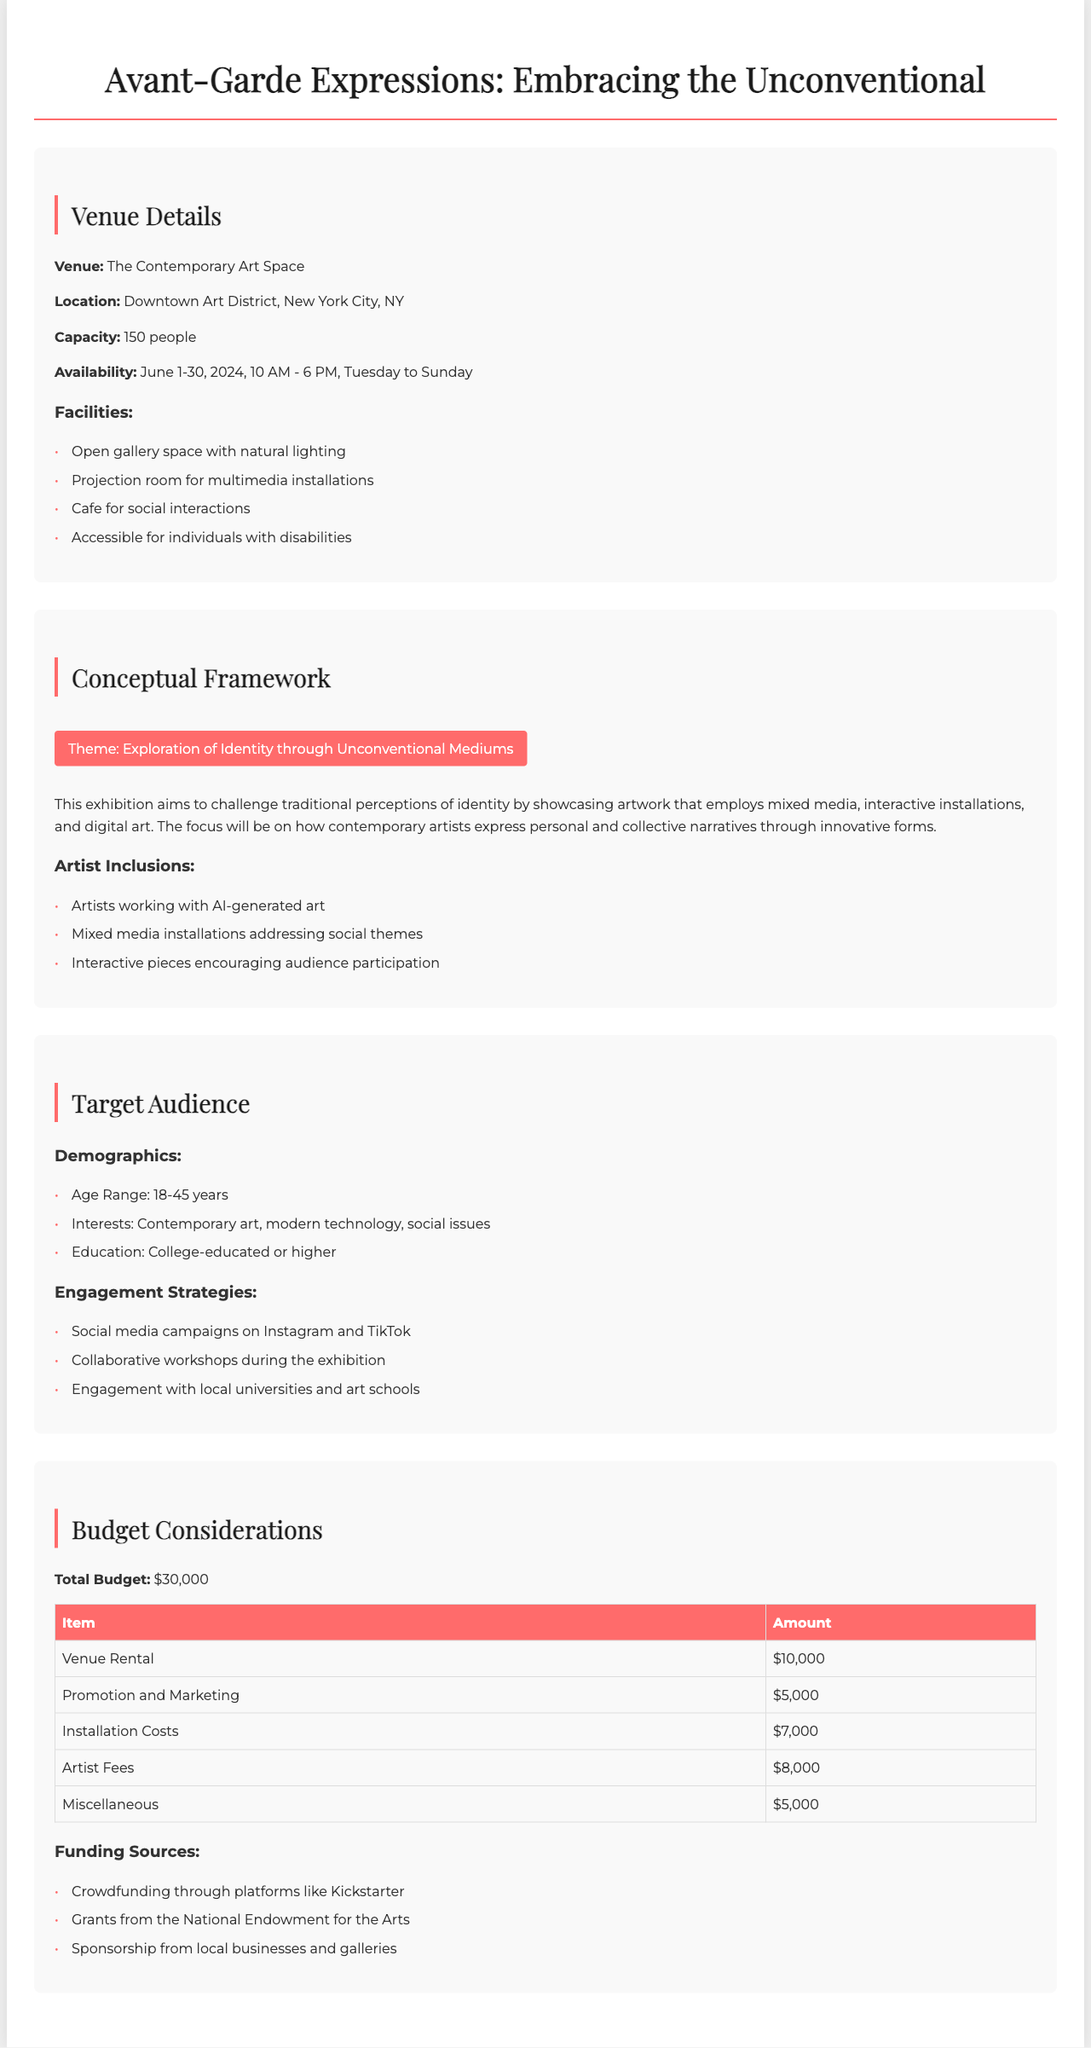What is the venue name? The venue name is mentioned in the document as "The Contemporary Art Space."
Answer: The Contemporary Art Space What is the location of the exhibition? The location is specified as "Downtown Art District, New York City, NY."
Answer: Downtown Art District, New York City, NY What is the total budget for the exhibition? The document directly states that the total budget is "$30,000."
Answer: $30,000 What theme is highlighted in the conceptual framework? The document emphasizes the theme as "Exploration of Identity through Unconventional Mediums."
Answer: Exploration of Identity through Unconventional Mediums What is the age range of the target audience? The age range for the target audience is provided as "18-45 years."
Answer: 18-45 years How many people can the venue accommodate? The capacity of the venue is stated as "150 people."
Answer: 150 people What type of engagement strategy is mentioned? The document lists strategies such as "Social media campaigns on Instagram and TikTok."
Answer: Social media campaigns on Instagram and TikTok What is the amount allocated for artist fees? The budget table indicates that artist fees amount to "$8,000."
Answer: $8,000 What are the facilities available at the venue? The document lists several facilities, including "Open gallery space with natural lighting."
Answer: Open gallery space with natural lighting 